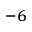<formula> <loc_0><loc_0><loc_500><loc_500>^ { - 6 }</formula> 